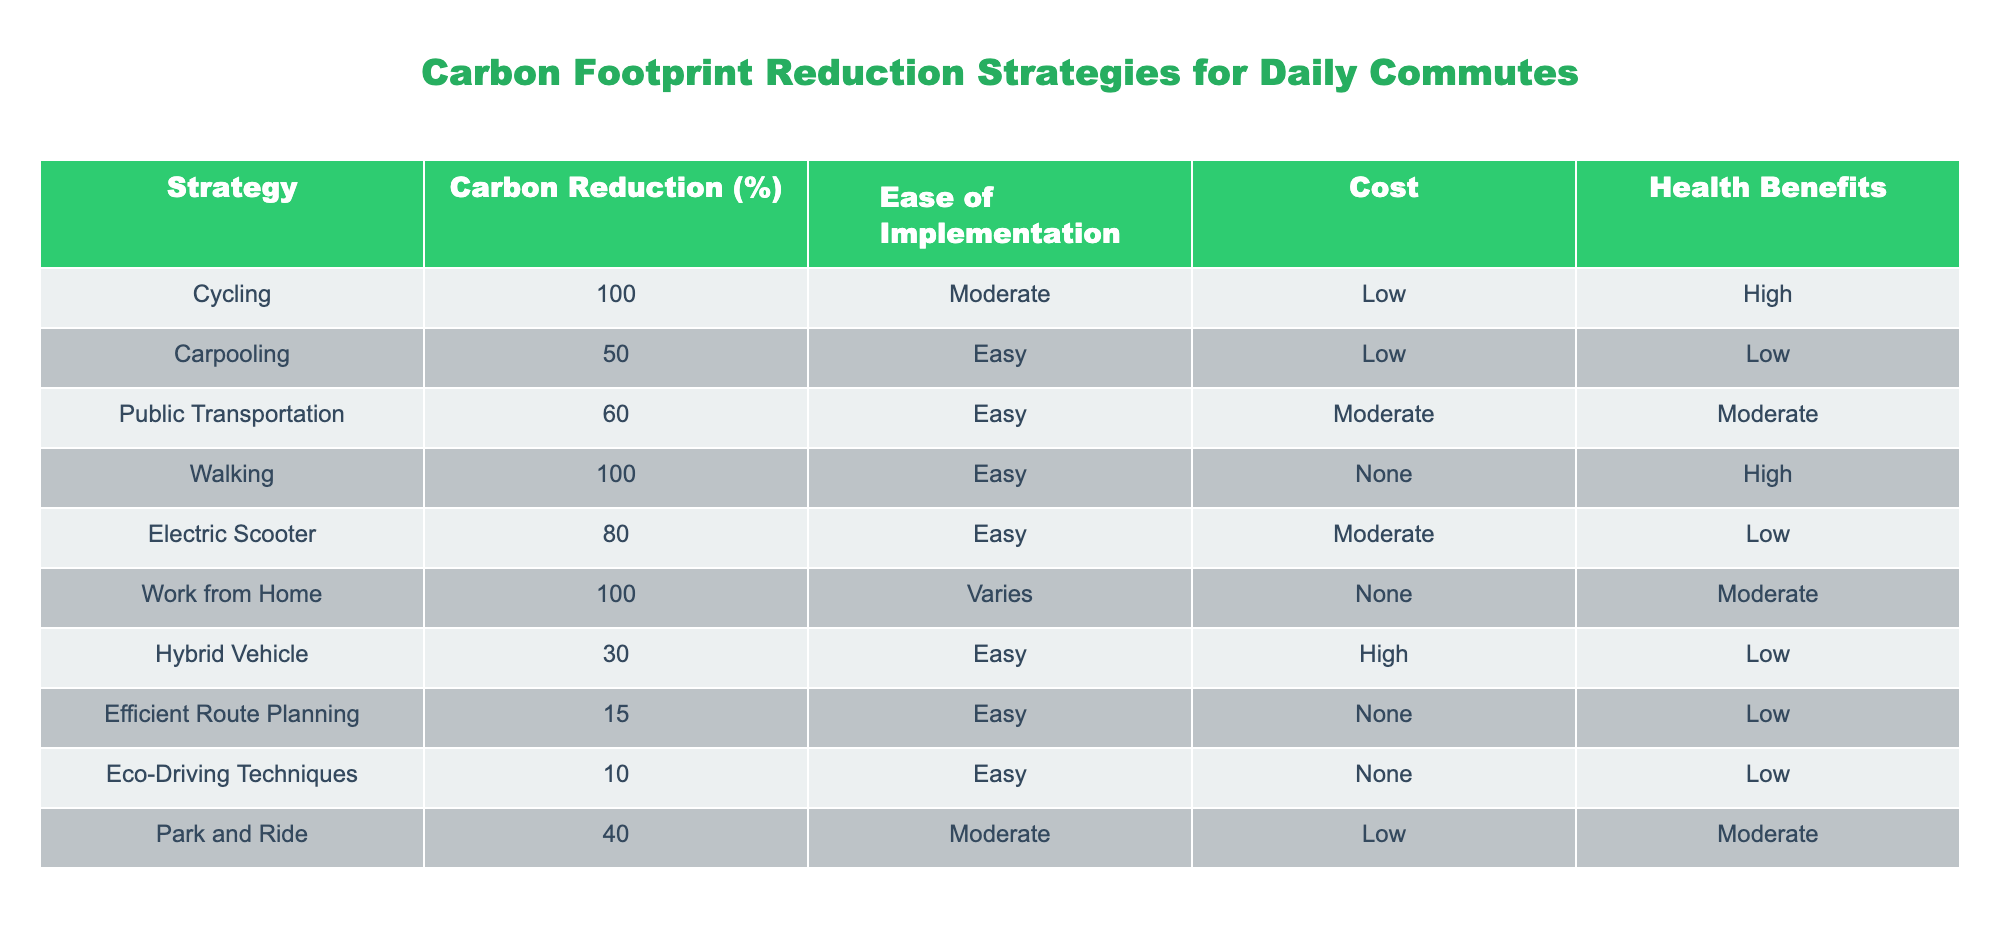What is the carbon reduction percentage for cycling? The value for cycling in the "Carbon Reduction (%)" column is directly listed as 100.
Answer: 100 Which strategy provides the lowest cost option? The strategies listed with "Low" in the "Cost" column are Carpooling, Park and Ride, and Cycling. Among these, both Carpooling and Park and Ride offer cost-effective choices, but the lowest cost option with no associated monetary cost is Walking.
Answer: Walking Is it true that all walking options provide high health benefits? The data shows that the "Health Benefits" for walking is classified as "High," but we need to check if any other strategies also indicate "High" health benefits. Cycling and Walking both have high health benefits. Thus, it’s true for Walking but not if generalized to all options. Therefore, the statement is partially true regarding Walking specifically.
Answer: True for Walking only What is the average carbon reduction percentage for strategies with easy implementation? Identifying the strategies with "Easy" implementation, we see Carpooling (50), Public Transportation (60), Walking (100), Electric Scooter (80), Hybrid Vehicle (30), Efficient Route Planning (15), Eco-Driving Techniques (10). To calculate the average, we sum these values: 50 + 60 + 100 + 80 + 30 + 15 + 10 = 345. There are 7 strategies, so the average is 345/7 = ~49.29.
Answer: Approximately 49.29 How many strategies have a carbon reduction percentage greater than 60%? The strategies with a carbon reduction greater than 60% are Cycling (100), Walking (100), Electric Scooter (80), and Work from Home (100). Counting these four strategies gives us a total of four strategies.
Answer: 4 